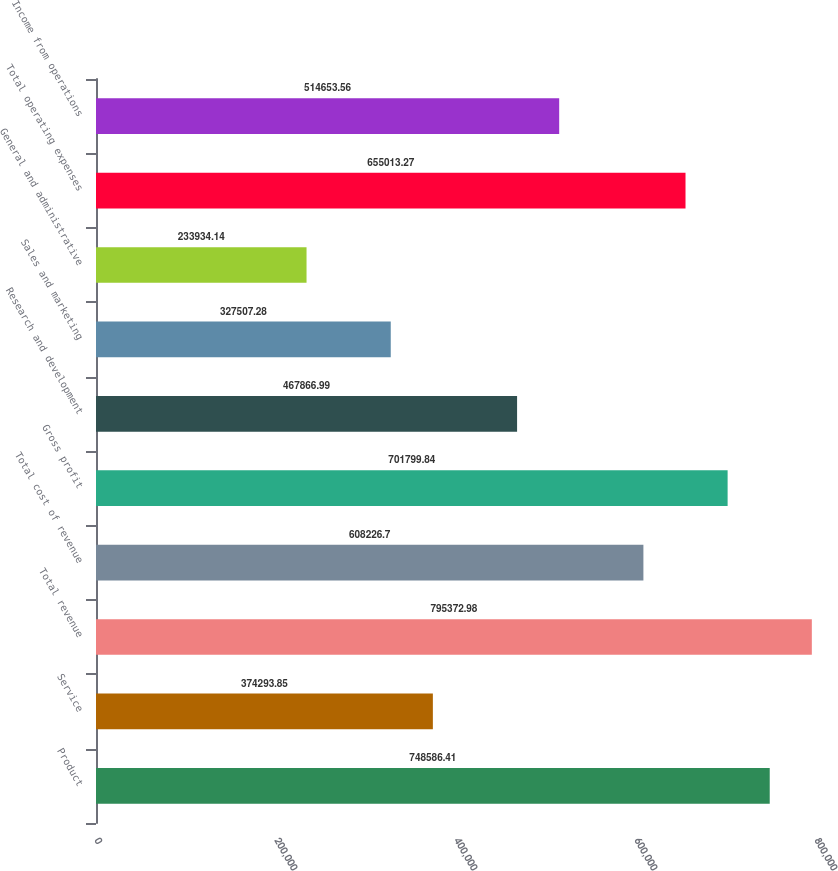<chart> <loc_0><loc_0><loc_500><loc_500><bar_chart><fcel>Product<fcel>Service<fcel>Total revenue<fcel>Total cost of revenue<fcel>Gross profit<fcel>Research and development<fcel>Sales and marketing<fcel>General and administrative<fcel>Total operating expenses<fcel>Income from operations<nl><fcel>748586<fcel>374294<fcel>795373<fcel>608227<fcel>701800<fcel>467867<fcel>327507<fcel>233934<fcel>655013<fcel>514654<nl></chart> 